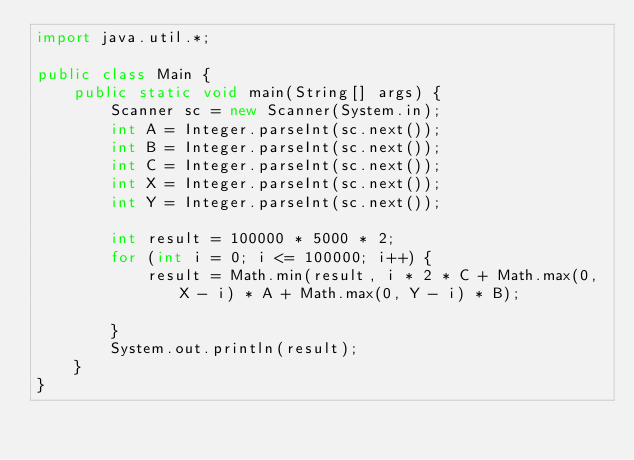<code> <loc_0><loc_0><loc_500><loc_500><_Java_>import java.util.*;

public class Main {
    public static void main(String[] args) {
        Scanner sc = new Scanner(System.in);
        int A = Integer.parseInt(sc.next());
        int B = Integer.parseInt(sc.next());
        int C = Integer.parseInt(sc.next());
        int X = Integer.parseInt(sc.next());
        int Y = Integer.parseInt(sc.next());

        int result = 100000 * 5000 * 2;
        for (int i = 0; i <= 100000; i++) {
            result = Math.min(result, i * 2 * C + Math.max(0, X - i) * A + Math.max(0, Y - i) * B);

        }
        System.out.println(result);
    }
}</code> 